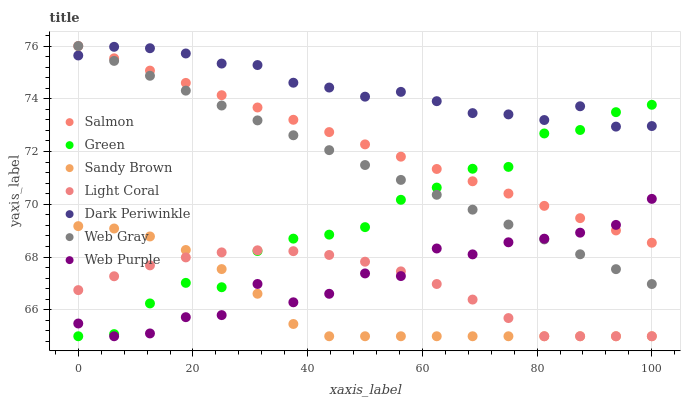Does Sandy Brown have the minimum area under the curve?
Answer yes or no. Yes. Does Dark Periwinkle have the maximum area under the curve?
Answer yes or no. Yes. Does Salmon have the minimum area under the curve?
Answer yes or no. No. Does Salmon have the maximum area under the curve?
Answer yes or no. No. Is Web Gray the smoothest?
Answer yes or no. Yes. Is Web Purple the roughest?
Answer yes or no. Yes. Is Salmon the smoothest?
Answer yes or no. No. Is Salmon the roughest?
Answer yes or no. No. Does Light Coral have the lowest value?
Answer yes or no. Yes. Does Salmon have the lowest value?
Answer yes or no. No. Does Salmon have the highest value?
Answer yes or no. Yes. Does Light Coral have the highest value?
Answer yes or no. No. Is Sandy Brown less than Dark Periwinkle?
Answer yes or no. Yes. Is Salmon greater than Light Coral?
Answer yes or no. Yes. Does Sandy Brown intersect Green?
Answer yes or no. Yes. Is Sandy Brown less than Green?
Answer yes or no. No. Is Sandy Brown greater than Green?
Answer yes or no. No. Does Sandy Brown intersect Dark Periwinkle?
Answer yes or no. No. 